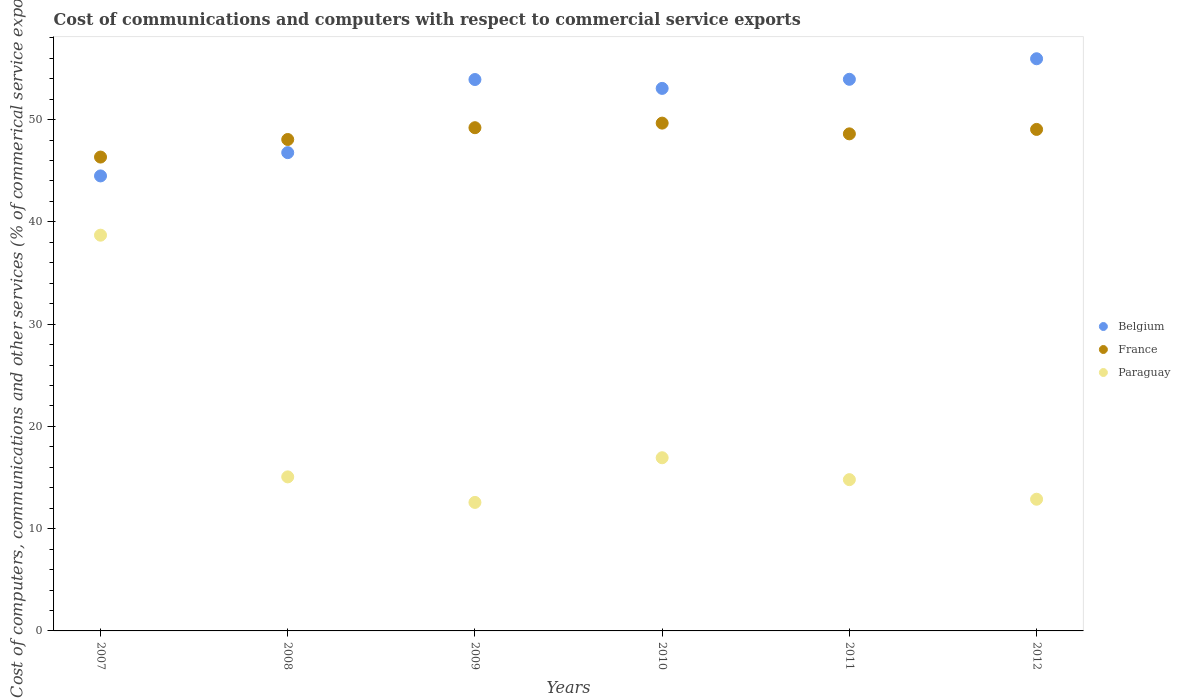What is the cost of communications and computers in Belgium in 2009?
Give a very brief answer. 53.91. Across all years, what is the maximum cost of communications and computers in Belgium?
Your answer should be compact. 55.94. Across all years, what is the minimum cost of communications and computers in France?
Give a very brief answer. 46.33. In which year was the cost of communications and computers in Belgium maximum?
Offer a very short reply. 2012. In which year was the cost of communications and computers in France minimum?
Your answer should be very brief. 2007. What is the total cost of communications and computers in France in the graph?
Provide a short and direct response. 290.87. What is the difference between the cost of communications and computers in Paraguay in 2008 and that in 2011?
Your answer should be compact. 0.27. What is the difference between the cost of communications and computers in Belgium in 2011 and the cost of communications and computers in Paraguay in 2008?
Keep it short and to the point. 38.87. What is the average cost of communications and computers in France per year?
Your answer should be very brief. 48.48. In the year 2012, what is the difference between the cost of communications and computers in Paraguay and cost of communications and computers in France?
Offer a very short reply. -36.16. In how many years, is the cost of communications and computers in Paraguay greater than 48 %?
Give a very brief answer. 0. What is the ratio of the cost of communications and computers in Paraguay in 2010 to that in 2011?
Provide a succinct answer. 1.14. Is the difference between the cost of communications and computers in Paraguay in 2007 and 2012 greater than the difference between the cost of communications and computers in France in 2007 and 2012?
Your response must be concise. Yes. What is the difference between the highest and the second highest cost of communications and computers in Paraguay?
Offer a terse response. 21.76. What is the difference between the highest and the lowest cost of communications and computers in Belgium?
Keep it short and to the point. 11.46. Is the sum of the cost of communications and computers in Paraguay in 2008 and 2009 greater than the maximum cost of communications and computers in Belgium across all years?
Keep it short and to the point. No. Is the cost of communications and computers in Belgium strictly greater than the cost of communications and computers in France over the years?
Offer a terse response. No. Is the cost of communications and computers in Paraguay strictly less than the cost of communications and computers in France over the years?
Offer a terse response. Yes. How many dotlines are there?
Make the answer very short. 3. Are the values on the major ticks of Y-axis written in scientific E-notation?
Keep it short and to the point. No. Does the graph contain grids?
Provide a short and direct response. No. How are the legend labels stacked?
Offer a very short reply. Vertical. What is the title of the graph?
Give a very brief answer. Cost of communications and computers with respect to commercial service exports. Does "Moldova" appear as one of the legend labels in the graph?
Your answer should be compact. No. What is the label or title of the Y-axis?
Provide a succinct answer. Cost of computers, communications and other services (% of commerical service exports). What is the Cost of computers, communications and other services (% of commerical service exports) of Belgium in 2007?
Your response must be concise. 44.49. What is the Cost of computers, communications and other services (% of commerical service exports) of France in 2007?
Offer a very short reply. 46.33. What is the Cost of computers, communications and other services (% of commerical service exports) in Paraguay in 2007?
Ensure brevity in your answer.  38.69. What is the Cost of computers, communications and other services (% of commerical service exports) in Belgium in 2008?
Provide a short and direct response. 46.76. What is the Cost of computers, communications and other services (% of commerical service exports) of France in 2008?
Provide a short and direct response. 48.05. What is the Cost of computers, communications and other services (% of commerical service exports) of Paraguay in 2008?
Give a very brief answer. 15.06. What is the Cost of computers, communications and other services (% of commerical service exports) in Belgium in 2009?
Provide a short and direct response. 53.91. What is the Cost of computers, communications and other services (% of commerical service exports) of France in 2009?
Offer a terse response. 49.2. What is the Cost of computers, communications and other services (% of commerical service exports) in Paraguay in 2009?
Make the answer very short. 12.56. What is the Cost of computers, communications and other services (% of commerical service exports) in Belgium in 2010?
Your response must be concise. 53.05. What is the Cost of computers, communications and other services (% of commerical service exports) in France in 2010?
Offer a terse response. 49.65. What is the Cost of computers, communications and other services (% of commerical service exports) in Paraguay in 2010?
Make the answer very short. 16.93. What is the Cost of computers, communications and other services (% of commerical service exports) of Belgium in 2011?
Provide a succinct answer. 53.93. What is the Cost of computers, communications and other services (% of commerical service exports) in France in 2011?
Keep it short and to the point. 48.6. What is the Cost of computers, communications and other services (% of commerical service exports) in Paraguay in 2011?
Your answer should be very brief. 14.79. What is the Cost of computers, communications and other services (% of commerical service exports) of Belgium in 2012?
Keep it short and to the point. 55.94. What is the Cost of computers, communications and other services (% of commerical service exports) of France in 2012?
Offer a terse response. 49.03. What is the Cost of computers, communications and other services (% of commerical service exports) in Paraguay in 2012?
Offer a very short reply. 12.88. Across all years, what is the maximum Cost of computers, communications and other services (% of commerical service exports) of Belgium?
Your answer should be compact. 55.94. Across all years, what is the maximum Cost of computers, communications and other services (% of commerical service exports) of France?
Ensure brevity in your answer.  49.65. Across all years, what is the maximum Cost of computers, communications and other services (% of commerical service exports) of Paraguay?
Offer a very short reply. 38.69. Across all years, what is the minimum Cost of computers, communications and other services (% of commerical service exports) of Belgium?
Offer a very short reply. 44.49. Across all years, what is the minimum Cost of computers, communications and other services (% of commerical service exports) in France?
Provide a short and direct response. 46.33. Across all years, what is the minimum Cost of computers, communications and other services (% of commerical service exports) of Paraguay?
Make the answer very short. 12.56. What is the total Cost of computers, communications and other services (% of commerical service exports) in Belgium in the graph?
Your answer should be compact. 308.09. What is the total Cost of computers, communications and other services (% of commerical service exports) of France in the graph?
Provide a short and direct response. 290.87. What is the total Cost of computers, communications and other services (% of commerical service exports) in Paraguay in the graph?
Provide a short and direct response. 110.92. What is the difference between the Cost of computers, communications and other services (% of commerical service exports) of Belgium in 2007 and that in 2008?
Offer a very short reply. -2.28. What is the difference between the Cost of computers, communications and other services (% of commerical service exports) in France in 2007 and that in 2008?
Your answer should be compact. -1.72. What is the difference between the Cost of computers, communications and other services (% of commerical service exports) in Paraguay in 2007 and that in 2008?
Provide a short and direct response. 23.63. What is the difference between the Cost of computers, communications and other services (% of commerical service exports) of Belgium in 2007 and that in 2009?
Give a very brief answer. -9.43. What is the difference between the Cost of computers, communications and other services (% of commerical service exports) in France in 2007 and that in 2009?
Keep it short and to the point. -2.87. What is the difference between the Cost of computers, communications and other services (% of commerical service exports) of Paraguay in 2007 and that in 2009?
Offer a terse response. 26.13. What is the difference between the Cost of computers, communications and other services (% of commerical service exports) of Belgium in 2007 and that in 2010?
Your answer should be compact. -8.56. What is the difference between the Cost of computers, communications and other services (% of commerical service exports) of France in 2007 and that in 2010?
Your answer should be compact. -3.32. What is the difference between the Cost of computers, communications and other services (% of commerical service exports) in Paraguay in 2007 and that in 2010?
Offer a terse response. 21.76. What is the difference between the Cost of computers, communications and other services (% of commerical service exports) in Belgium in 2007 and that in 2011?
Give a very brief answer. -9.45. What is the difference between the Cost of computers, communications and other services (% of commerical service exports) of France in 2007 and that in 2011?
Ensure brevity in your answer.  -2.27. What is the difference between the Cost of computers, communications and other services (% of commerical service exports) in Paraguay in 2007 and that in 2011?
Your answer should be compact. 23.9. What is the difference between the Cost of computers, communications and other services (% of commerical service exports) in Belgium in 2007 and that in 2012?
Keep it short and to the point. -11.46. What is the difference between the Cost of computers, communications and other services (% of commerical service exports) of France in 2007 and that in 2012?
Your answer should be compact. -2.7. What is the difference between the Cost of computers, communications and other services (% of commerical service exports) of Paraguay in 2007 and that in 2012?
Provide a short and direct response. 25.82. What is the difference between the Cost of computers, communications and other services (% of commerical service exports) in Belgium in 2008 and that in 2009?
Give a very brief answer. -7.15. What is the difference between the Cost of computers, communications and other services (% of commerical service exports) in France in 2008 and that in 2009?
Provide a short and direct response. -1.15. What is the difference between the Cost of computers, communications and other services (% of commerical service exports) of Paraguay in 2008 and that in 2009?
Provide a short and direct response. 2.5. What is the difference between the Cost of computers, communications and other services (% of commerical service exports) of Belgium in 2008 and that in 2010?
Give a very brief answer. -6.28. What is the difference between the Cost of computers, communications and other services (% of commerical service exports) of France in 2008 and that in 2010?
Offer a terse response. -1.6. What is the difference between the Cost of computers, communications and other services (% of commerical service exports) of Paraguay in 2008 and that in 2010?
Your answer should be very brief. -1.87. What is the difference between the Cost of computers, communications and other services (% of commerical service exports) of Belgium in 2008 and that in 2011?
Keep it short and to the point. -7.17. What is the difference between the Cost of computers, communications and other services (% of commerical service exports) of France in 2008 and that in 2011?
Provide a short and direct response. -0.55. What is the difference between the Cost of computers, communications and other services (% of commerical service exports) of Paraguay in 2008 and that in 2011?
Your answer should be compact. 0.27. What is the difference between the Cost of computers, communications and other services (% of commerical service exports) in Belgium in 2008 and that in 2012?
Make the answer very short. -9.18. What is the difference between the Cost of computers, communications and other services (% of commerical service exports) in France in 2008 and that in 2012?
Provide a succinct answer. -0.99. What is the difference between the Cost of computers, communications and other services (% of commerical service exports) in Paraguay in 2008 and that in 2012?
Give a very brief answer. 2.18. What is the difference between the Cost of computers, communications and other services (% of commerical service exports) in Belgium in 2009 and that in 2010?
Offer a very short reply. 0.87. What is the difference between the Cost of computers, communications and other services (% of commerical service exports) in France in 2009 and that in 2010?
Your answer should be compact. -0.45. What is the difference between the Cost of computers, communications and other services (% of commerical service exports) of Paraguay in 2009 and that in 2010?
Give a very brief answer. -4.37. What is the difference between the Cost of computers, communications and other services (% of commerical service exports) in Belgium in 2009 and that in 2011?
Provide a succinct answer. -0.02. What is the difference between the Cost of computers, communications and other services (% of commerical service exports) of France in 2009 and that in 2011?
Your response must be concise. 0.6. What is the difference between the Cost of computers, communications and other services (% of commerical service exports) of Paraguay in 2009 and that in 2011?
Make the answer very short. -2.23. What is the difference between the Cost of computers, communications and other services (% of commerical service exports) of Belgium in 2009 and that in 2012?
Your answer should be compact. -2.03. What is the difference between the Cost of computers, communications and other services (% of commerical service exports) of France in 2009 and that in 2012?
Provide a succinct answer. 0.17. What is the difference between the Cost of computers, communications and other services (% of commerical service exports) of Paraguay in 2009 and that in 2012?
Ensure brevity in your answer.  -0.31. What is the difference between the Cost of computers, communications and other services (% of commerical service exports) in Belgium in 2010 and that in 2011?
Offer a terse response. -0.89. What is the difference between the Cost of computers, communications and other services (% of commerical service exports) in France in 2010 and that in 2011?
Keep it short and to the point. 1.05. What is the difference between the Cost of computers, communications and other services (% of commerical service exports) in Paraguay in 2010 and that in 2011?
Give a very brief answer. 2.14. What is the difference between the Cost of computers, communications and other services (% of commerical service exports) in Belgium in 2010 and that in 2012?
Your answer should be very brief. -2.9. What is the difference between the Cost of computers, communications and other services (% of commerical service exports) in France in 2010 and that in 2012?
Offer a terse response. 0.62. What is the difference between the Cost of computers, communications and other services (% of commerical service exports) in Paraguay in 2010 and that in 2012?
Provide a succinct answer. 4.06. What is the difference between the Cost of computers, communications and other services (% of commerical service exports) of Belgium in 2011 and that in 2012?
Keep it short and to the point. -2.01. What is the difference between the Cost of computers, communications and other services (% of commerical service exports) in France in 2011 and that in 2012?
Your answer should be compact. -0.43. What is the difference between the Cost of computers, communications and other services (% of commerical service exports) of Paraguay in 2011 and that in 2012?
Ensure brevity in your answer.  1.91. What is the difference between the Cost of computers, communications and other services (% of commerical service exports) of Belgium in 2007 and the Cost of computers, communications and other services (% of commerical service exports) of France in 2008?
Offer a very short reply. -3.56. What is the difference between the Cost of computers, communications and other services (% of commerical service exports) of Belgium in 2007 and the Cost of computers, communications and other services (% of commerical service exports) of Paraguay in 2008?
Offer a terse response. 29.43. What is the difference between the Cost of computers, communications and other services (% of commerical service exports) of France in 2007 and the Cost of computers, communications and other services (% of commerical service exports) of Paraguay in 2008?
Keep it short and to the point. 31.27. What is the difference between the Cost of computers, communications and other services (% of commerical service exports) of Belgium in 2007 and the Cost of computers, communications and other services (% of commerical service exports) of France in 2009?
Provide a succinct answer. -4.71. What is the difference between the Cost of computers, communications and other services (% of commerical service exports) of Belgium in 2007 and the Cost of computers, communications and other services (% of commerical service exports) of Paraguay in 2009?
Give a very brief answer. 31.92. What is the difference between the Cost of computers, communications and other services (% of commerical service exports) of France in 2007 and the Cost of computers, communications and other services (% of commerical service exports) of Paraguay in 2009?
Give a very brief answer. 33.77. What is the difference between the Cost of computers, communications and other services (% of commerical service exports) of Belgium in 2007 and the Cost of computers, communications and other services (% of commerical service exports) of France in 2010?
Offer a terse response. -5.16. What is the difference between the Cost of computers, communications and other services (% of commerical service exports) of Belgium in 2007 and the Cost of computers, communications and other services (% of commerical service exports) of Paraguay in 2010?
Your answer should be compact. 27.56. What is the difference between the Cost of computers, communications and other services (% of commerical service exports) of France in 2007 and the Cost of computers, communications and other services (% of commerical service exports) of Paraguay in 2010?
Ensure brevity in your answer.  29.4. What is the difference between the Cost of computers, communications and other services (% of commerical service exports) in Belgium in 2007 and the Cost of computers, communications and other services (% of commerical service exports) in France in 2011?
Offer a very short reply. -4.11. What is the difference between the Cost of computers, communications and other services (% of commerical service exports) in Belgium in 2007 and the Cost of computers, communications and other services (% of commerical service exports) in Paraguay in 2011?
Ensure brevity in your answer.  29.7. What is the difference between the Cost of computers, communications and other services (% of commerical service exports) of France in 2007 and the Cost of computers, communications and other services (% of commerical service exports) of Paraguay in 2011?
Provide a short and direct response. 31.54. What is the difference between the Cost of computers, communications and other services (% of commerical service exports) of Belgium in 2007 and the Cost of computers, communications and other services (% of commerical service exports) of France in 2012?
Your answer should be very brief. -4.55. What is the difference between the Cost of computers, communications and other services (% of commerical service exports) in Belgium in 2007 and the Cost of computers, communications and other services (% of commerical service exports) in Paraguay in 2012?
Provide a short and direct response. 31.61. What is the difference between the Cost of computers, communications and other services (% of commerical service exports) in France in 2007 and the Cost of computers, communications and other services (% of commerical service exports) in Paraguay in 2012?
Ensure brevity in your answer.  33.46. What is the difference between the Cost of computers, communications and other services (% of commerical service exports) in Belgium in 2008 and the Cost of computers, communications and other services (% of commerical service exports) in France in 2009?
Your response must be concise. -2.44. What is the difference between the Cost of computers, communications and other services (% of commerical service exports) in Belgium in 2008 and the Cost of computers, communications and other services (% of commerical service exports) in Paraguay in 2009?
Your answer should be very brief. 34.2. What is the difference between the Cost of computers, communications and other services (% of commerical service exports) in France in 2008 and the Cost of computers, communications and other services (% of commerical service exports) in Paraguay in 2009?
Your answer should be very brief. 35.48. What is the difference between the Cost of computers, communications and other services (% of commerical service exports) of Belgium in 2008 and the Cost of computers, communications and other services (% of commerical service exports) of France in 2010?
Keep it short and to the point. -2.89. What is the difference between the Cost of computers, communications and other services (% of commerical service exports) of Belgium in 2008 and the Cost of computers, communications and other services (% of commerical service exports) of Paraguay in 2010?
Your response must be concise. 29.83. What is the difference between the Cost of computers, communications and other services (% of commerical service exports) of France in 2008 and the Cost of computers, communications and other services (% of commerical service exports) of Paraguay in 2010?
Provide a succinct answer. 31.12. What is the difference between the Cost of computers, communications and other services (% of commerical service exports) of Belgium in 2008 and the Cost of computers, communications and other services (% of commerical service exports) of France in 2011?
Ensure brevity in your answer.  -1.84. What is the difference between the Cost of computers, communications and other services (% of commerical service exports) in Belgium in 2008 and the Cost of computers, communications and other services (% of commerical service exports) in Paraguay in 2011?
Ensure brevity in your answer.  31.97. What is the difference between the Cost of computers, communications and other services (% of commerical service exports) of France in 2008 and the Cost of computers, communications and other services (% of commerical service exports) of Paraguay in 2011?
Your answer should be compact. 33.26. What is the difference between the Cost of computers, communications and other services (% of commerical service exports) in Belgium in 2008 and the Cost of computers, communications and other services (% of commerical service exports) in France in 2012?
Ensure brevity in your answer.  -2.27. What is the difference between the Cost of computers, communications and other services (% of commerical service exports) in Belgium in 2008 and the Cost of computers, communications and other services (% of commerical service exports) in Paraguay in 2012?
Your answer should be compact. 33.89. What is the difference between the Cost of computers, communications and other services (% of commerical service exports) in France in 2008 and the Cost of computers, communications and other services (% of commerical service exports) in Paraguay in 2012?
Ensure brevity in your answer.  35.17. What is the difference between the Cost of computers, communications and other services (% of commerical service exports) of Belgium in 2009 and the Cost of computers, communications and other services (% of commerical service exports) of France in 2010?
Offer a very short reply. 4.26. What is the difference between the Cost of computers, communications and other services (% of commerical service exports) in Belgium in 2009 and the Cost of computers, communications and other services (% of commerical service exports) in Paraguay in 2010?
Provide a short and direct response. 36.98. What is the difference between the Cost of computers, communications and other services (% of commerical service exports) in France in 2009 and the Cost of computers, communications and other services (% of commerical service exports) in Paraguay in 2010?
Your response must be concise. 32.27. What is the difference between the Cost of computers, communications and other services (% of commerical service exports) of Belgium in 2009 and the Cost of computers, communications and other services (% of commerical service exports) of France in 2011?
Provide a short and direct response. 5.31. What is the difference between the Cost of computers, communications and other services (% of commerical service exports) in Belgium in 2009 and the Cost of computers, communications and other services (% of commerical service exports) in Paraguay in 2011?
Offer a very short reply. 39.12. What is the difference between the Cost of computers, communications and other services (% of commerical service exports) in France in 2009 and the Cost of computers, communications and other services (% of commerical service exports) in Paraguay in 2011?
Keep it short and to the point. 34.41. What is the difference between the Cost of computers, communications and other services (% of commerical service exports) in Belgium in 2009 and the Cost of computers, communications and other services (% of commerical service exports) in France in 2012?
Your answer should be very brief. 4.88. What is the difference between the Cost of computers, communications and other services (% of commerical service exports) of Belgium in 2009 and the Cost of computers, communications and other services (% of commerical service exports) of Paraguay in 2012?
Give a very brief answer. 41.04. What is the difference between the Cost of computers, communications and other services (% of commerical service exports) of France in 2009 and the Cost of computers, communications and other services (% of commerical service exports) of Paraguay in 2012?
Keep it short and to the point. 36.33. What is the difference between the Cost of computers, communications and other services (% of commerical service exports) of Belgium in 2010 and the Cost of computers, communications and other services (% of commerical service exports) of France in 2011?
Offer a terse response. 4.44. What is the difference between the Cost of computers, communications and other services (% of commerical service exports) in Belgium in 2010 and the Cost of computers, communications and other services (% of commerical service exports) in Paraguay in 2011?
Your response must be concise. 38.25. What is the difference between the Cost of computers, communications and other services (% of commerical service exports) of France in 2010 and the Cost of computers, communications and other services (% of commerical service exports) of Paraguay in 2011?
Make the answer very short. 34.86. What is the difference between the Cost of computers, communications and other services (% of commerical service exports) of Belgium in 2010 and the Cost of computers, communications and other services (% of commerical service exports) of France in 2012?
Your answer should be compact. 4.01. What is the difference between the Cost of computers, communications and other services (% of commerical service exports) in Belgium in 2010 and the Cost of computers, communications and other services (% of commerical service exports) in Paraguay in 2012?
Your answer should be very brief. 40.17. What is the difference between the Cost of computers, communications and other services (% of commerical service exports) of France in 2010 and the Cost of computers, communications and other services (% of commerical service exports) of Paraguay in 2012?
Make the answer very short. 36.77. What is the difference between the Cost of computers, communications and other services (% of commerical service exports) of Belgium in 2011 and the Cost of computers, communications and other services (% of commerical service exports) of France in 2012?
Your response must be concise. 4.9. What is the difference between the Cost of computers, communications and other services (% of commerical service exports) in Belgium in 2011 and the Cost of computers, communications and other services (% of commerical service exports) in Paraguay in 2012?
Offer a terse response. 41.06. What is the difference between the Cost of computers, communications and other services (% of commerical service exports) of France in 2011 and the Cost of computers, communications and other services (% of commerical service exports) of Paraguay in 2012?
Your answer should be compact. 35.72. What is the average Cost of computers, communications and other services (% of commerical service exports) of Belgium per year?
Give a very brief answer. 51.35. What is the average Cost of computers, communications and other services (% of commerical service exports) of France per year?
Give a very brief answer. 48.48. What is the average Cost of computers, communications and other services (% of commerical service exports) in Paraguay per year?
Your answer should be very brief. 18.49. In the year 2007, what is the difference between the Cost of computers, communications and other services (% of commerical service exports) in Belgium and Cost of computers, communications and other services (% of commerical service exports) in France?
Give a very brief answer. -1.84. In the year 2007, what is the difference between the Cost of computers, communications and other services (% of commerical service exports) of Belgium and Cost of computers, communications and other services (% of commerical service exports) of Paraguay?
Your answer should be compact. 5.79. In the year 2007, what is the difference between the Cost of computers, communications and other services (% of commerical service exports) in France and Cost of computers, communications and other services (% of commerical service exports) in Paraguay?
Keep it short and to the point. 7.64. In the year 2008, what is the difference between the Cost of computers, communications and other services (% of commerical service exports) of Belgium and Cost of computers, communications and other services (% of commerical service exports) of France?
Provide a succinct answer. -1.28. In the year 2008, what is the difference between the Cost of computers, communications and other services (% of commerical service exports) of Belgium and Cost of computers, communications and other services (% of commerical service exports) of Paraguay?
Your response must be concise. 31.7. In the year 2008, what is the difference between the Cost of computers, communications and other services (% of commerical service exports) of France and Cost of computers, communications and other services (% of commerical service exports) of Paraguay?
Give a very brief answer. 32.99. In the year 2009, what is the difference between the Cost of computers, communications and other services (% of commerical service exports) of Belgium and Cost of computers, communications and other services (% of commerical service exports) of France?
Your response must be concise. 4.71. In the year 2009, what is the difference between the Cost of computers, communications and other services (% of commerical service exports) of Belgium and Cost of computers, communications and other services (% of commerical service exports) of Paraguay?
Your answer should be very brief. 41.35. In the year 2009, what is the difference between the Cost of computers, communications and other services (% of commerical service exports) in France and Cost of computers, communications and other services (% of commerical service exports) in Paraguay?
Provide a short and direct response. 36.64. In the year 2010, what is the difference between the Cost of computers, communications and other services (% of commerical service exports) in Belgium and Cost of computers, communications and other services (% of commerical service exports) in France?
Keep it short and to the point. 3.4. In the year 2010, what is the difference between the Cost of computers, communications and other services (% of commerical service exports) in Belgium and Cost of computers, communications and other services (% of commerical service exports) in Paraguay?
Make the answer very short. 36.11. In the year 2010, what is the difference between the Cost of computers, communications and other services (% of commerical service exports) in France and Cost of computers, communications and other services (% of commerical service exports) in Paraguay?
Offer a very short reply. 32.72. In the year 2011, what is the difference between the Cost of computers, communications and other services (% of commerical service exports) in Belgium and Cost of computers, communications and other services (% of commerical service exports) in France?
Offer a very short reply. 5.33. In the year 2011, what is the difference between the Cost of computers, communications and other services (% of commerical service exports) of Belgium and Cost of computers, communications and other services (% of commerical service exports) of Paraguay?
Ensure brevity in your answer.  39.14. In the year 2011, what is the difference between the Cost of computers, communications and other services (% of commerical service exports) in France and Cost of computers, communications and other services (% of commerical service exports) in Paraguay?
Ensure brevity in your answer.  33.81. In the year 2012, what is the difference between the Cost of computers, communications and other services (% of commerical service exports) in Belgium and Cost of computers, communications and other services (% of commerical service exports) in France?
Ensure brevity in your answer.  6.91. In the year 2012, what is the difference between the Cost of computers, communications and other services (% of commerical service exports) in Belgium and Cost of computers, communications and other services (% of commerical service exports) in Paraguay?
Your response must be concise. 43.07. In the year 2012, what is the difference between the Cost of computers, communications and other services (% of commerical service exports) of France and Cost of computers, communications and other services (% of commerical service exports) of Paraguay?
Make the answer very short. 36.16. What is the ratio of the Cost of computers, communications and other services (% of commerical service exports) of Belgium in 2007 to that in 2008?
Provide a short and direct response. 0.95. What is the ratio of the Cost of computers, communications and other services (% of commerical service exports) in France in 2007 to that in 2008?
Your response must be concise. 0.96. What is the ratio of the Cost of computers, communications and other services (% of commerical service exports) in Paraguay in 2007 to that in 2008?
Keep it short and to the point. 2.57. What is the ratio of the Cost of computers, communications and other services (% of commerical service exports) of Belgium in 2007 to that in 2009?
Your response must be concise. 0.83. What is the ratio of the Cost of computers, communications and other services (% of commerical service exports) of France in 2007 to that in 2009?
Keep it short and to the point. 0.94. What is the ratio of the Cost of computers, communications and other services (% of commerical service exports) of Paraguay in 2007 to that in 2009?
Offer a very short reply. 3.08. What is the ratio of the Cost of computers, communications and other services (% of commerical service exports) of Belgium in 2007 to that in 2010?
Ensure brevity in your answer.  0.84. What is the ratio of the Cost of computers, communications and other services (% of commerical service exports) of France in 2007 to that in 2010?
Keep it short and to the point. 0.93. What is the ratio of the Cost of computers, communications and other services (% of commerical service exports) in Paraguay in 2007 to that in 2010?
Ensure brevity in your answer.  2.29. What is the ratio of the Cost of computers, communications and other services (% of commerical service exports) in Belgium in 2007 to that in 2011?
Keep it short and to the point. 0.82. What is the ratio of the Cost of computers, communications and other services (% of commerical service exports) of France in 2007 to that in 2011?
Provide a succinct answer. 0.95. What is the ratio of the Cost of computers, communications and other services (% of commerical service exports) of Paraguay in 2007 to that in 2011?
Provide a succinct answer. 2.62. What is the ratio of the Cost of computers, communications and other services (% of commerical service exports) of Belgium in 2007 to that in 2012?
Make the answer very short. 0.8. What is the ratio of the Cost of computers, communications and other services (% of commerical service exports) of France in 2007 to that in 2012?
Keep it short and to the point. 0.94. What is the ratio of the Cost of computers, communications and other services (% of commerical service exports) in Paraguay in 2007 to that in 2012?
Offer a very short reply. 3. What is the ratio of the Cost of computers, communications and other services (% of commerical service exports) in Belgium in 2008 to that in 2009?
Your answer should be compact. 0.87. What is the ratio of the Cost of computers, communications and other services (% of commerical service exports) in France in 2008 to that in 2009?
Give a very brief answer. 0.98. What is the ratio of the Cost of computers, communications and other services (% of commerical service exports) in Paraguay in 2008 to that in 2009?
Offer a very short reply. 1.2. What is the ratio of the Cost of computers, communications and other services (% of commerical service exports) in Belgium in 2008 to that in 2010?
Offer a very short reply. 0.88. What is the ratio of the Cost of computers, communications and other services (% of commerical service exports) of France in 2008 to that in 2010?
Your answer should be very brief. 0.97. What is the ratio of the Cost of computers, communications and other services (% of commerical service exports) of Paraguay in 2008 to that in 2010?
Your answer should be compact. 0.89. What is the ratio of the Cost of computers, communications and other services (% of commerical service exports) in Belgium in 2008 to that in 2011?
Offer a terse response. 0.87. What is the ratio of the Cost of computers, communications and other services (% of commerical service exports) of France in 2008 to that in 2011?
Your response must be concise. 0.99. What is the ratio of the Cost of computers, communications and other services (% of commerical service exports) of Paraguay in 2008 to that in 2011?
Your answer should be compact. 1.02. What is the ratio of the Cost of computers, communications and other services (% of commerical service exports) of Belgium in 2008 to that in 2012?
Provide a succinct answer. 0.84. What is the ratio of the Cost of computers, communications and other services (% of commerical service exports) of France in 2008 to that in 2012?
Provide a short and direct response. 0.98. What is the ratio of the Cost of computers, communications and other services (% of commerical service exports) of Paraguay in 2008 to that in 2012?
Your response must be concise. 1.17. What is the ratio of the Cost of computers, communications and other services (% of commerical service exports) in Belgium in 2009 to that in 2010?
Offer a very short reply. 1.02. What is the ratio of the Cost of computers, communications and other services (% of commerical service exports) of France in 2009 to that in 2010?
Your response must be concise. 0.99. What is the ratio of the Cost of computers, communications and other services (% of commerical service exports) in Paraguay in 2009 to that in 2010?
Your answer should be compact. 0.74. What is the ratio of the Cost of computers, communications and other services (% of commerical service exports) of France in 2009 to that in 2011?
Your answer should be compact. 1.01. What is the ratio of the Cost of computers, communications and other services (% of commerical service exports) of Paraguay in 2009 to that in 2011?
Your response must be concise. 0.85. What is the ratio of the Cost of computers, communications and other services (% of commerical service exports) of Belgium in 2009 to that in 2012?
Ensure brevity in your answer.  0.96. What is the ratio of the Cost of computers, communications and other services (% of commerical service exports) of Paraguay in 2009 to that in 2012?
Provide a succinct answer. 0.98. What is the ratio of the Cost of computers, communications and other services (% of commerical service exports) of Belgium in 2010 to that in 2011?
Provide a succinct answer. 0.98. What is the ratio of the Cost of computers, communications and other services (% of commerical service exports) in France in 2010 to that in 2011?
Provide a succinct answer. 1.02. What is the ratio of the Cost of computers, communications and other services (% of commerical service exports) of Paraguay in 2010 to that in 2011?
Provide a short and direct response. 1.14. What is the ratio of the Cost of computers, communications and other services (% of commerical service exports) in Belgium in 2010 to that in 2012?
Offer a very short reply. 0.95. What is the ratio of the Cost of computers, communications and other services (% of commerical service exports) of France in 2010 to that in 2012?
Your response must be concise. 1.01. What is the ratio of the Cost of computers, communications and other services (% of commerical service exports) in Paraguay in 2010 to that in 2012?
Your answer should be very brief. 1.31. What is the ratio of the Cost of computers, communications and other services (% of commerical service exports) in Belgium in 2011 to that in 2012?
Offer a very short reply. 0.96. What is the ratio of the Cost of computers, communications and other services (% of commerical service exports) of Paraguay in 2011 to that in 2012?
Provide a succinct answer. 1.15. What is the difference between the highest and the second highest Cost of computers, communications and other services (% of commerical service exports) of Belgium?
Provide a short and direct response. 2.01. What is the difference between the highest and the second highest Cost of computers, communications and other services (% of commerical service exports) of France?
Provide a short and direct response. 0.45. What is the difference between the highest and the second highest Cost of computers, communications and other services (% of commerical service exports) in Paraguay?
Your answer should be very brief. 21.76. What is the difference between the highest and the lowest Cost of computers, communications and other services (% of commerical service exports) in Belgium?
Offer a terse response. 11.46. What is the difference between the highest and the lowest Cost of computers, communications and other services (% of commerical service exports) in France?
Your answer should be compact. 3.32. What is the difference between the highest and the lowest Cost of computers, communications and other services (% of commerical service exports) of Paraguay?
Provide a succinct answer. 26.13. 